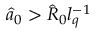Convert formula to latex. <formula><loc_0><loc_0><loc_500><loc_500>\hat { a } _ { 0 } > \hat { R } _ { 0 } l _ { q } ^ { - 1 }</formula> 